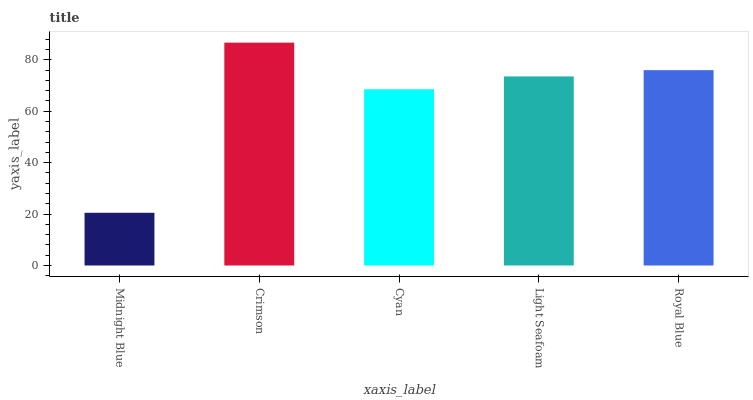Is Midnight Blue the minimum?
Answer yes or no. Yes. Is Crimson the maximum?
Answer yes or no. Yes. Is Cyan the minimum?
Answer yes or no. No. Is Cyan the maximum?
Answer yes or no. No. Is Crimson greater than Cyan?
Answer yes or no. Yes. Is Cyan less than Crimson?
Answer yes or no. Yes. Is Cyan greater than Crimson?
Answer yes or no. No. Is Crimson less than Cyan?
Answer yes or no. No. Is Light Seafoam the high median?
Answer yes or no. Yes. Is Light Seafoam the low median?
Answer yes or no. Yes. Is Midnight Blue the high median?
Answer yes or no. No. Is Cyan the low median?
Answer yes or no. No. 